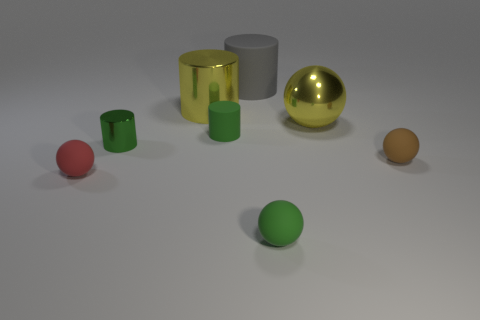Subtract all red matte spheres. How many spheres are left? 3 Subtract all brown spheres. How many green cylinders are left? 2 Subtract all gray cylinders. How many cylinders are left? 3 Add 1 brown things. How many objects exist? 9 Subtract all gray spheres. Subtract all cyan cylinders. How many spheres are left? 4 Add 6 small green shiny cylinders. How many small green shiny cylinders are left? 7 Add 3 rubber balls. How many rubber balls exist? 6 Subtract 0 purple cubes. How many objects are left? 8 Subtract all tiny green cylinders. Subtract all gray rubber cylinders. How many objects are left? 5 